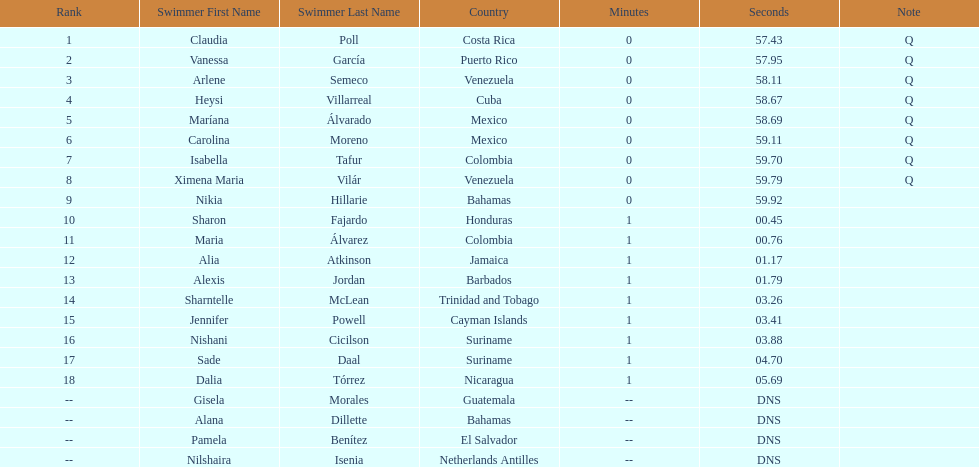Would you be able to parse every entry in this table? {'header': ['Rank', 'Swimmer First Name', 'Swimmer Last Name', 'Country', 'Minutes', 'Seconds', 'Note'], 'rows': [['1', 'Claudia', 'Poll', 'Costa Rica', '0', '57.43', 'Q'], ['2', 'Vanessa', 'García', 'Puerto Rico', '0', '57.95', 'Q'], ['3', 'Arlene', 'Semeco', 'Venezuela', '0', '58.11', 'Q'], ['4', 'Heysi', 'Villarreal', 'Cuba', '0', '58.67', 'Q'], ['5', 'Maríana', 'Álvarado', 'Mexico', '0', '58.69', 'Q'], ['6', 'Carolina', 'Moreno', 'Mexico', '0', '59.11', 'Q'], ['7', 'Isabella', 'Tafur', 'Colombia', '0', '59.70', 'Q'], ['8', 'Ximena Maria', 'Vilár', 'Venezuela', '0', '59.79', 'Q'], ['9', 'Nikia', 'Hillarie', 'Bahamas', '0', '59.92', ''], ['10', 'Sharon', 'Fajardo', 'Honduras', '1', '00.45', ''], ['11', 'Maria', 'Álvarez', 'Colombia', '1', '00.76', ''], ['12', 'Alia', 'Atkinson', 'Jamaica', '1', '01.17', ''], ['13', 'Alexis', 'Jordan', 'Barbados', '1', '01.79', ''], ['14', 'Sharntelle', 'McLean', 'Trinidad and Tobago', '1', '03.26', ''], ['15', 'Jennifer', 'Powell', 'Cayman Islands', '1', '03.41', ''], ['16', 'Nishani', 'Cicilson', 'Suriname', '1', '03.88', ''], ['17', 'Sade', 'Daal', 'Suriname', '1', '04.70', ''], ['18', 'Dalia', 'Tórrez', 'Nicaragua', '1', '05.69', ''], ['--', 'Gisela', 'Morales', 'Guatemala', '--', 'DNS', ''], ['--', 'Alana', 'Dillette', 'Bahamas', '--', 'DNS', ''], ['--', 'Pamela', 'Benítez', 'El Salvador', '--', 'DNS', ''], ['--', 'Nilshaira', 'Isenia', 'Netherlands Antilles', '--', 'DNS', '']]} Which swimmer had the longest time? Dalia Tórrez. 